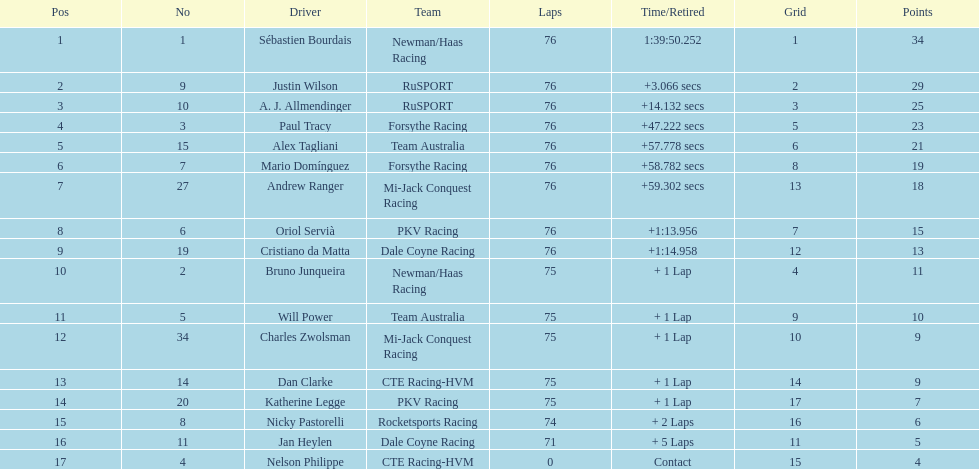Which driver possesses the minimum number of points? Nelson Philippe. 